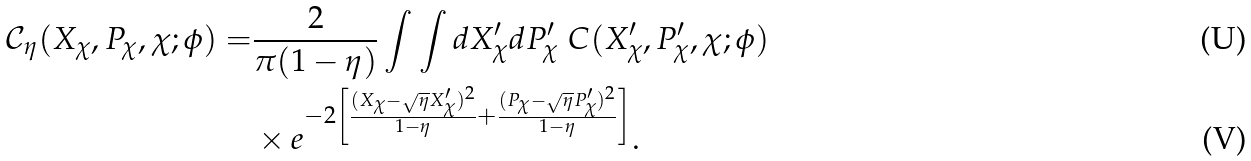Convert formula to latex. <formula><loc_0><loc_0><loc_500><loc_500>\mathcal { C } _ { \eta } ( X _ { \chi } , P _ { \chi } , \chi ; \phi ) = & \frac { 2 } { \pi ( 1 - \eta ) } \int \int d X ^ { \prime } _ { \chi } d P ^ { \prime } _ { \chi } \ C ( X ^ { \prime } _ { \chi } , P ^ { \prime } _ { \chi } , \chi ; \phi ) \\ & \times e ^ { - 2 \left [ \frac { ( X _ { \chi } - \sqrt { \eta } X ^ { \prime } _ { \chi } ) ^ { 2 } } { 1 - \eta } + \frac { ( P _ { \chi } - \sqrt { \eta } P ^ { \prime } _ { \chi } ) ^ { 2 } } { 1 - \eta } \right ] } .</formula> 